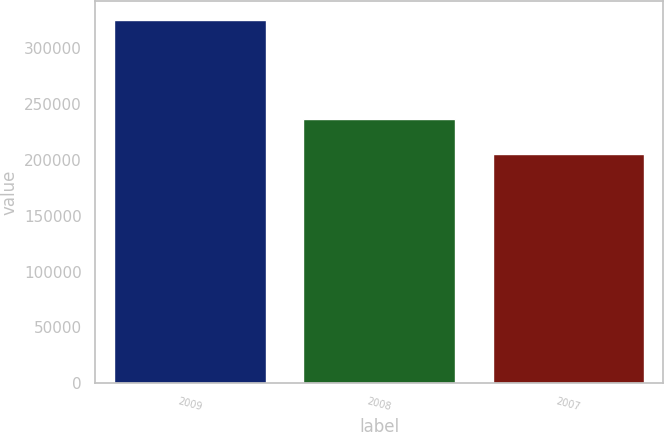<chart> <loc_0><loc_0><loc_500><loc_500><bar_chart><fcel>2009<fcel>2008<fcel>2007<nl><fcel>325633<fcel>236956<fcel>205688<nl></chart> 